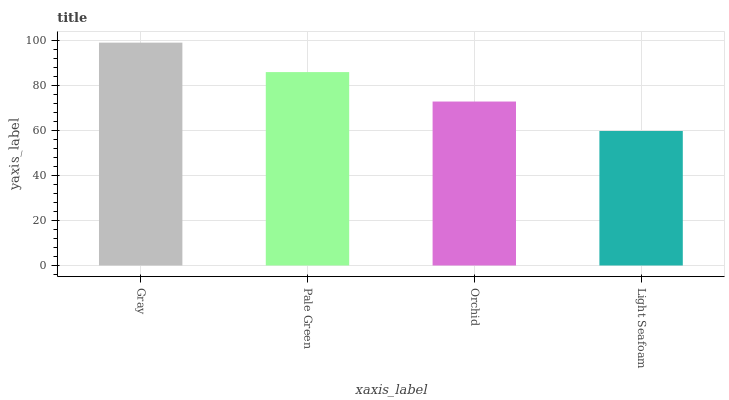Is Light Seafoam the minimum?
Answer yes or no. Yes. Is Gray the maximum?
Answer yes or no. Yes. Is Pale Green the minimum?
Answer yes or no. No. Is Pale Green the maximum?
Answer yes or no. No. Is Gray greater than Pale Green?
Answer yes or no. Yes. Is Pale Green less than Gray?
Answer yes or no. Yes. Is Pale Green greater than Gray?
Answer yes or no. No. Is Gray less than Pale Green?
Answer yes or no. No. Is Pale Green the high median?
Answer yes or no. Yes. Is Orchid the low median?
Answer yes or no. Yes. Is Orchid the high median?
Answer yes or no. No. Is Light Seafoam the low median?
Answer yes or no. No. 